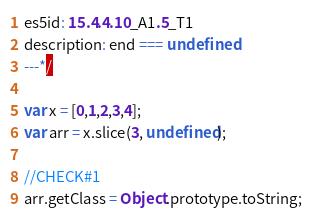<code> <loc_0><loc_0><loc_500><loc_500><_JavaScript_>es5id: 15.4.4.10_A1.5_T1
description: end === undefined
---*/

var x = [0,1,2,3,4];
var arr = x.slice(3, undefined);

//CHECK#1
arr.getClass = Object.prototype.toString;</code> 